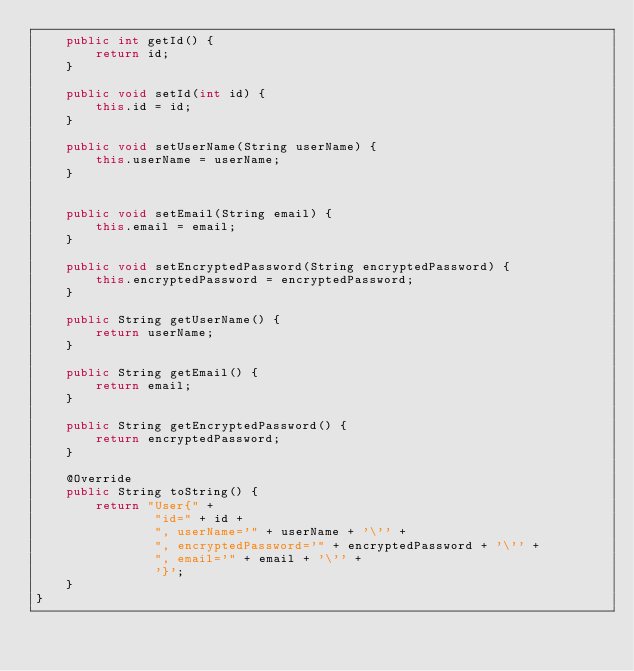Convert code to text. <code><loc_0><loc_0><loc_500><loc_500><_Java_>    public int getId() {
        return id;
    }

    public void setId(int id) {
        this.id = id;
    }

    public void setUserName(String userName) {
        this.userName = userName;
    }


    public void setEmail(String email) {
        this.email = email;
    }

    public void setEncryptedPassword(String encryptedPassword) {
        this.encryptedPassword = encryptedPassword;
    }

    public String getUserName() {
        return userName;
    }

    public String getEmail() {
        return email;
    }

    public String getEncryptedPassword() {
        return encryptedPassword;
    }

    @Override
    public String toString() {
        return "User{" +
                "id=" + id +
                ", userName='" + userName + '\'' +
                ", encryptedPassword='" + encryptedPassword + '\'' +
                ", email='" + email + '\'' +
                '}';
    }
}
</code> 